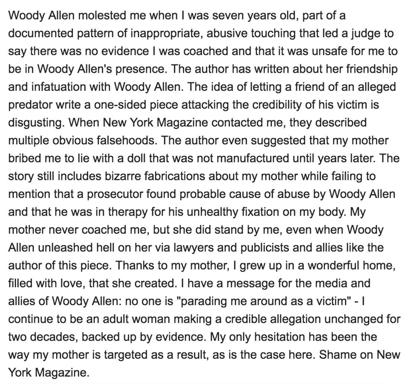How does the author describe her feelings towards her mother in the text? The author expresses a deep reverence and gratitude towards her mother, describing her as a consistent and comforting presence even amidst the allegations against Woody Allen. She credits her mother for her resilience and the loving and wholesome home environment she provided. 